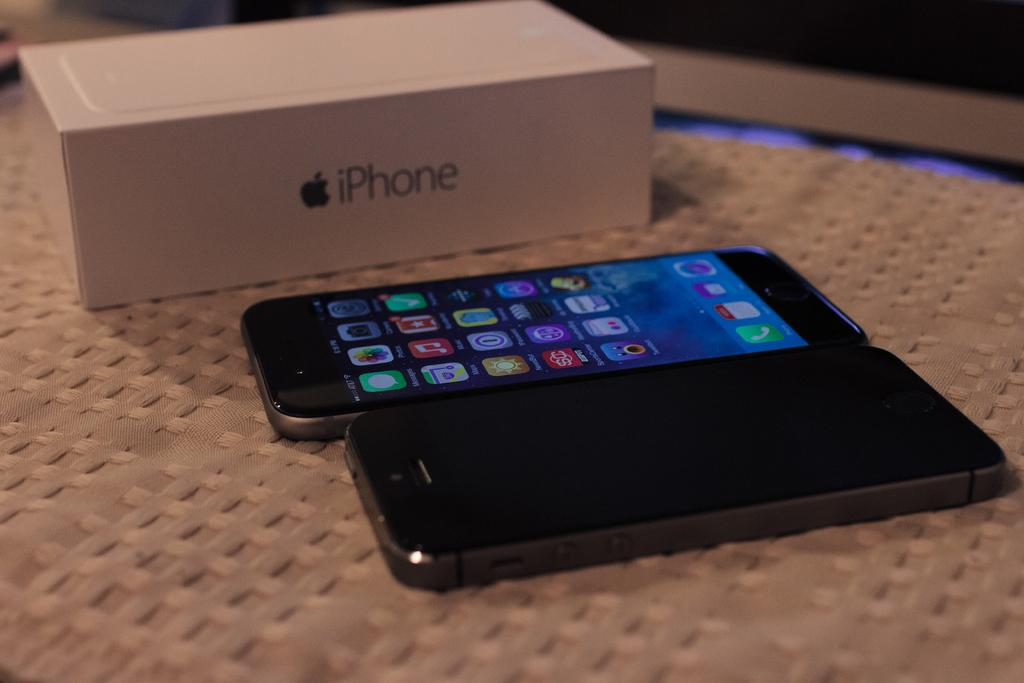Provide a one-sentence caption for the provided image. Two cell phones are sitting near a white iPhone box. 